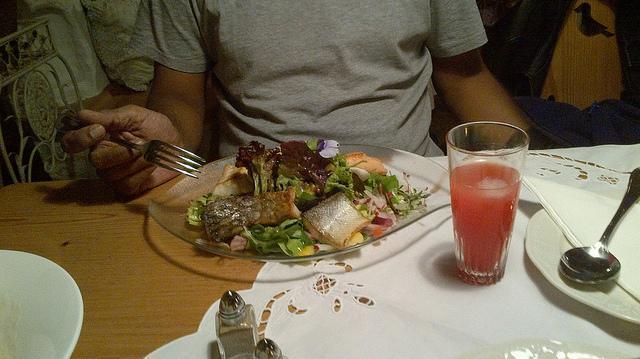How many prongs does the fork have?
Give a very brief answer. 4. How many plates of food are sitting on this white table?
Give a very brief answer. 1. How many serving utensils are on the table?
Give a very brief answer. 2. How many straws in the picture?
Give a very brief answer. 0. How many people are there?
Give a very brief answer. 2. 